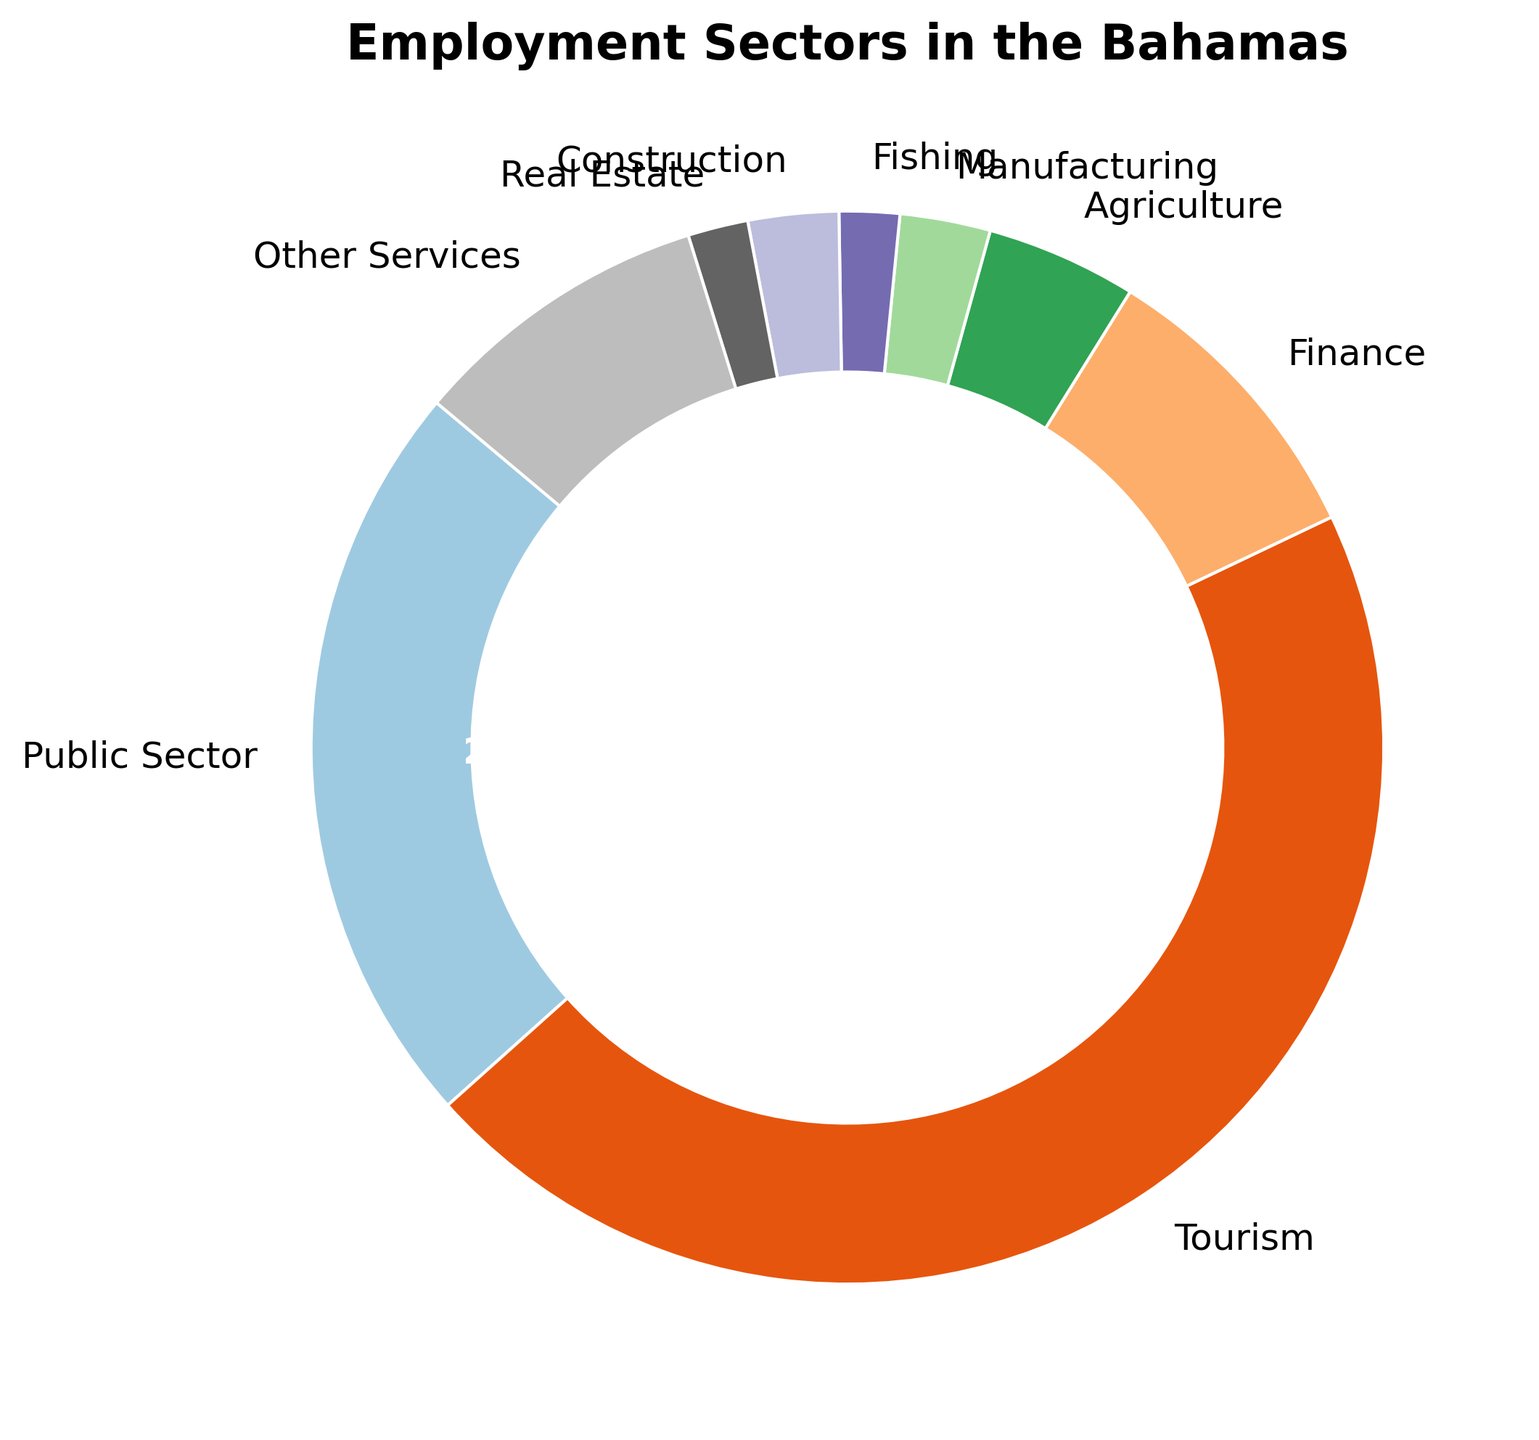What's the largest employment sector according to the chart? The chart shows the percentages of different employment sectors in the Bahamas. The sector with the biggest slice of the ring chart is the largest employment sector.
Answer: Tourism Which sector employs more people, Agriculture or Finance? The chart shows Agriculture has 5% and Finance has 10%. Since 10% is greater than 5%, Finance employs more people.
Answer: Finance What is the combined percentage of people employed in Fishing and Construction? Fishing employs 2% and Construction employs 3%. Adding these together: 2% + 3% = 5%.
Answer: 5% What is the difference in employment percentages between Tourism and the Public Sector? Tourism employs 50% and the Public Sector employs 25%. The difference is 50% - 25% = 25%.
Answer: 25% How does the proportion of people employed in Real Estate compare to that in Manufacturing? The chart shows that Real Estate accounts for 2% of employment and Manufacturing accounts for 3%. Since 2% is less than 3%, Real Estate employs fewer people than Manufacturing.
Answer: Less Which sectors employ an equal percentage of people? The chart indicates that both Fishing and Real Estate employ 2% of people each.
Answer: Fishing and Real Estate If you combine the percentages of Finance and Other Services, what portion of the chart would they collectively represent? Finance represents 10% and Other Services represent 10%. Adding these together: 10% + 10% = 20%.
Answer: 20% Rank the top three sectors in terms of employment. The sectors are ranked based on their percentages as follows: 1) Tourism (50%), 2) Public Sector (25%), 3) Finance (10%).
Answer: Tourism, Public Sector, Finance By what factor does the employment in Tourism exceed that of Agriculture? Tourism employs 50% and Agriculture employs 5%. The factor by which Tourism exceeds Agriculture is 50% / 5% = 10.
Answer: 10 Which sector has a larger share, Other Services or Manufacturing? The chart shows that both Manufacturing and Other Services each have 3% and 10% respectively. Since 10% is more than 3%, Other Services has a larger share.
Answer: Other Services 